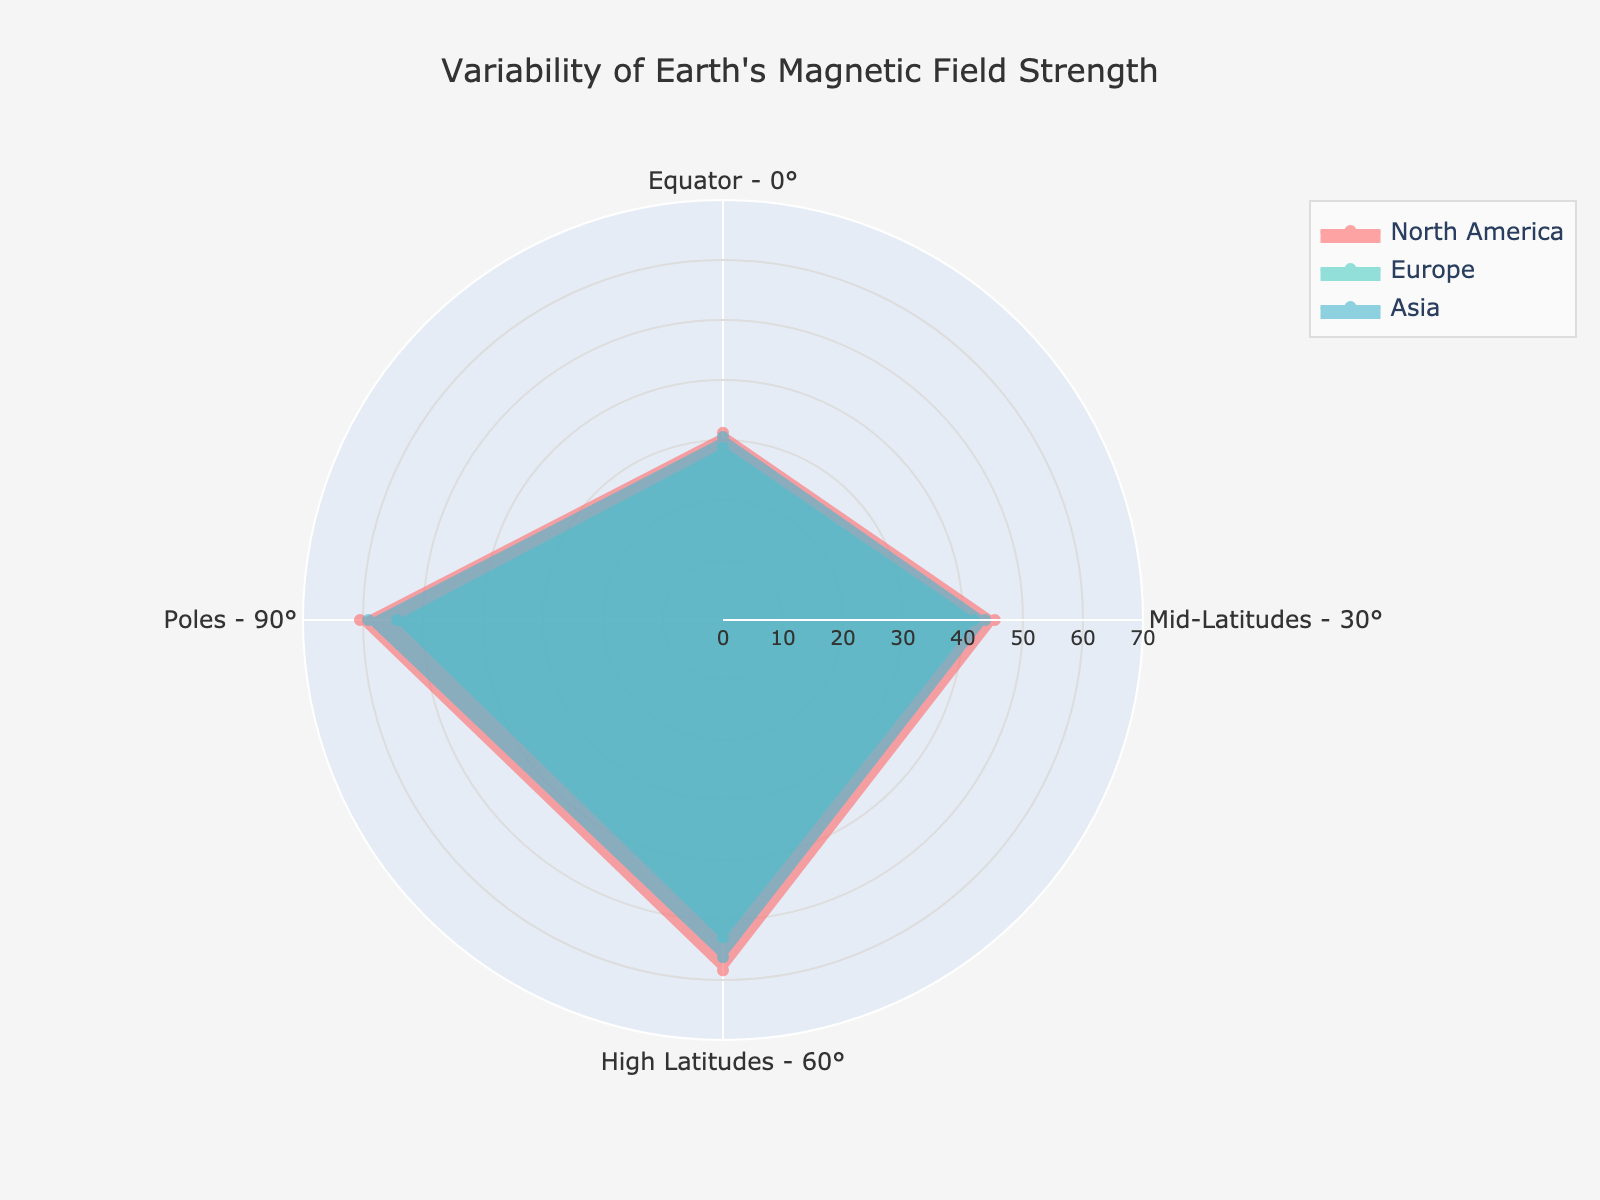What is the title of the radar chart? The title is usually at the top of the chart. Reading the top, we see the title is 'Variability of Earth's Magnetic Field Strength'.
Answer: Variability of Earth's Magnetic Field Strength Which region has the highest magnetic field strength at the poles (90°)? The poles' strength can be compared on the radar chart by looking at the outermost data point for each region at the 90° mark. North America has the highest value here at 60.5.
Answer: North America What is the range of the radial axis on the radar chart? We look at the radial axis, the axis extending outward from the center, usually labeled with range values. The range is from 0 to 70.
Answer: 0 to 70 Which region shows the smallest magnetic field strength at the Equator (0°)? At the Equator's 0° mark on the radar chart, the smallest data point among all regions is 28.7 for Europe.
Answer: Europe What is the average magnetic field strength at mid-latitudes (30°) for all regions? Add the values at 30° for all regions and divide by the number of regions. (45.3 + 41.8 + 43.7)/3 = 43.6
Answer: 43.6 How do the magnetic field strengths at high latitudes (60°) compare between North America and Europe? By examining the radar chart at 60°, North America's value is 58.4 and Europe's value is 52.9. North America's value is higher.
Answer: North America is higher Which region has the most uniform magnetic field strength across the different latitudes? The most uniform values will have the least deviation. Checking all latitudes, Europe's values (28.7, 41.8, 52.9, 54.3) show less variability compared to others.
Answer: Europe What is the sum of the magnetic field strengths at the poles (90°) for all regions? Add the values at 90° for all regions. 60.5 (North America) + 54.3 (Europe) + 59.1 (Asia) = 173.9
Answer: 173.9 How does Asia's magnetic field strength at mid-latitudes (30°) compare to its strength at high latitudes (60°)? Looking at the radar chart for Asia, mid-latitudes (30°) value is 43.7 and high latitudes (60°) value is 56.2. Asia's magnetic field strength at 60° is higher than at 30°.
Answer: Higher at 60° Which region exhibits the largest increase in magnetic field strength from equator (0°) to poles (90°)? Subtract the value at equator from the value at poles for each region. North America: 60.5 - 31.2 = 29.3, Europe: 54.3 - 28.7 = 25.6, Asia: 59.1 - 30.5 = 28.6. North America has the largest increase.
Answer: North America 